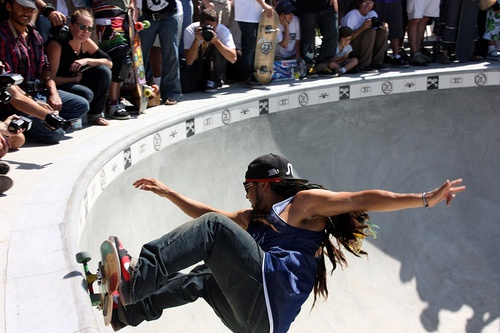Describe the objects in this image and their specific colors. I can see people in black, gray, maroon, and lightgray tones, people in black, maroon, gray, and lightpink tones, people in black, maroon, gray, and brown tones, people in black, gray, and maroon tones, and people in black, gray, navy, and darkgray tones in this image. 